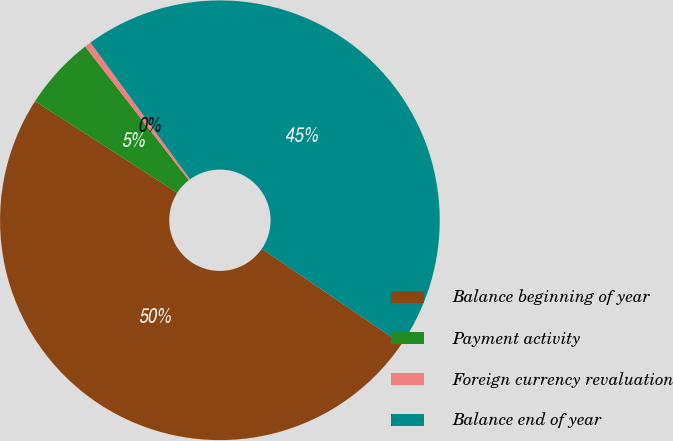<chart> <loc_0><loc_0><loc_500><loc_500><pie_chart><fcel>Balance beginning of year<fcel>Payment activity<fcel>Foreign currency revaluation<fcel>Balance end of year<nl><fcel>49.61%<fcel>5.39%<fcel>0.48%<fcel>44.53%<nl></chart> 